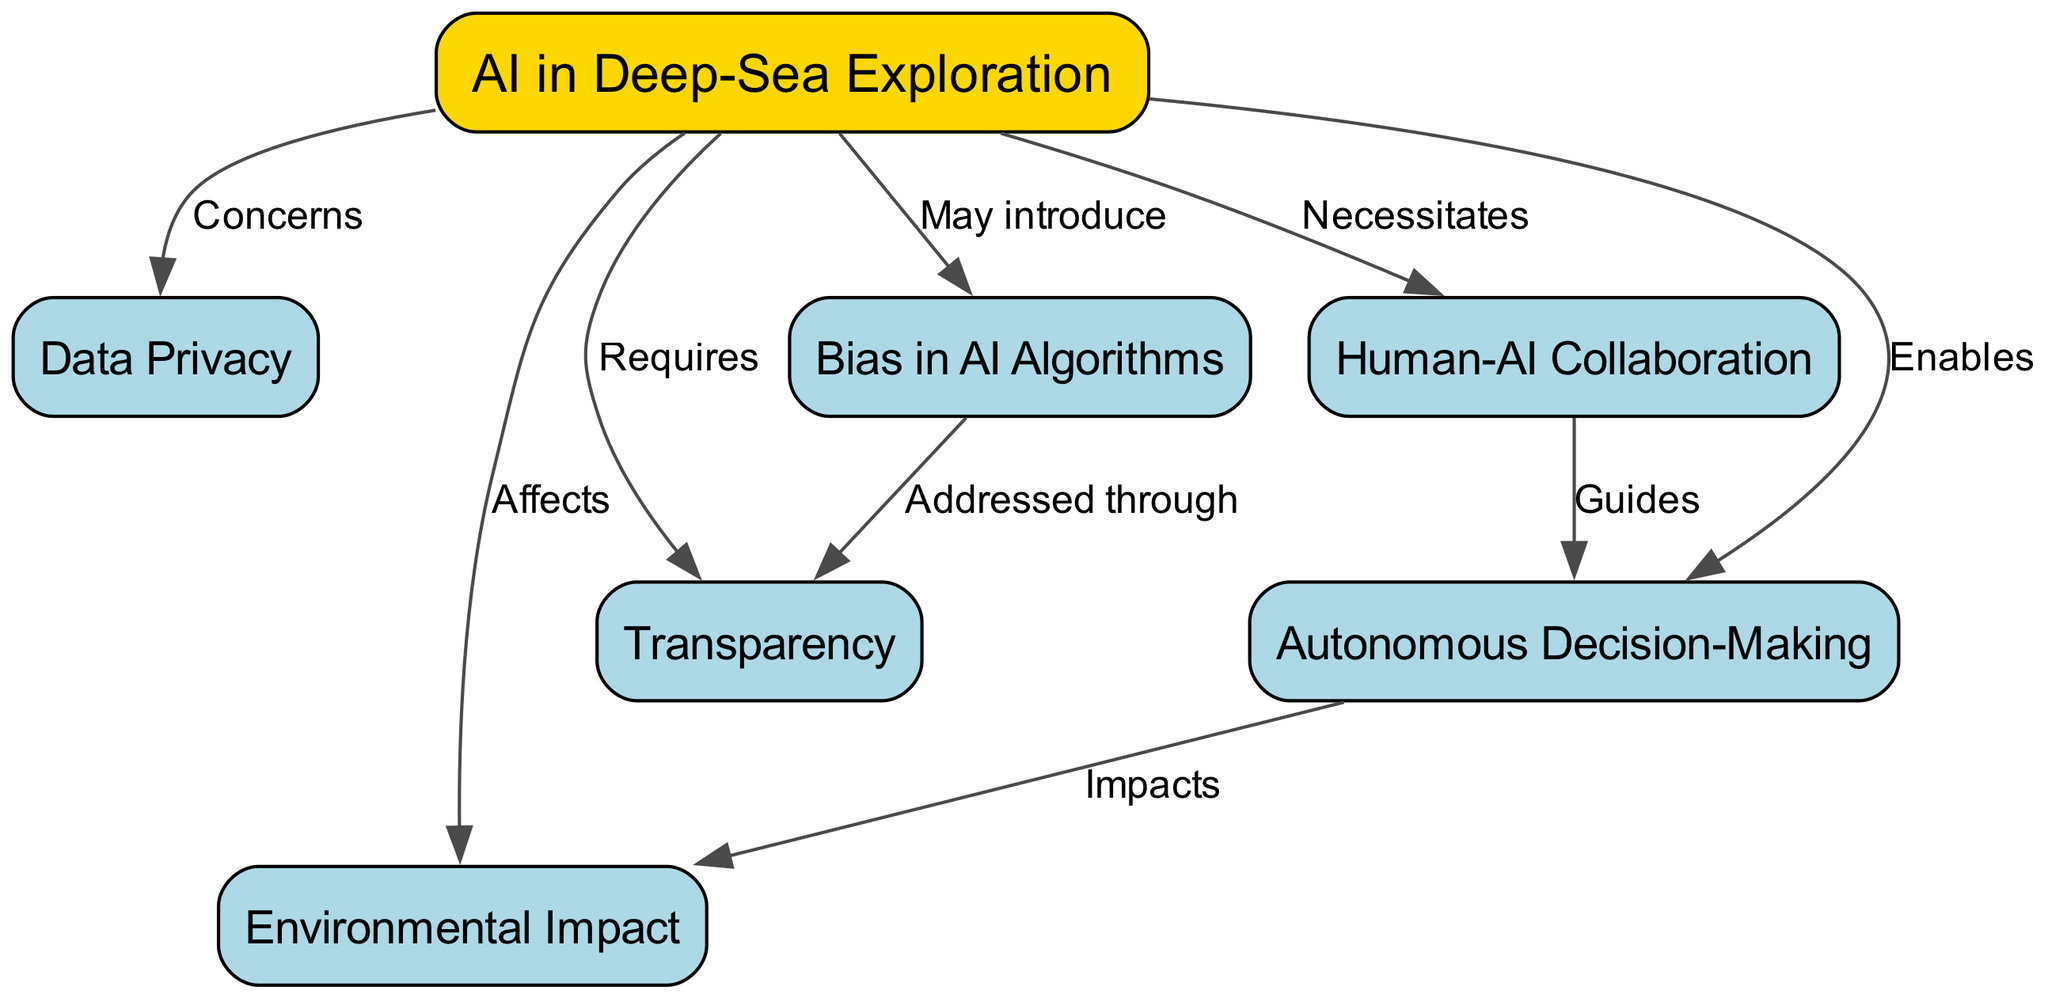What is the main topic of the concept map? The central node labeled "AI in Deep-Sea Exploration" represents the main topic around which the other nodes are connected. This node is emphasized by being the only one filled with gold.
Answer: AI in Deep-Sea Exploration How many total nodes are there in the diagram? Counting the nodes listed, there are seven distinct nodes: AI in Deep-Sea Exploration, Data Privacy, Environmental Impact, Autonomous Decision-Making, Transparency, Bias in AI Algorithms, and Human-AI Collaboration.
Answer: 7 What concern is related to Data Privacy? The diagram shows that Data Privacy is a concern stemming from "AI in Deep-Sea Exploration," as indicated by the edge labeled "Concerns."
Answer: Concerns What does Autonomous Decision-Making enable in the context of the diagram? The edge labeled "Enables" connects "AI in Deep-Sea Exploration" to "Autonomous Decision-Making," indicating that the application of AI facilitates the ability to make autonomous decisions in deep-sea exploration.
Answer: Enables How does Bias in AI Algorithms connect with Transparency? The diagram indicates that "Bias in AI Algorithms" can be addressed through "Transparency," establishing a connection where improving transparency may help mitigate bias issues in AI models.
Answer: Addressed through What impact does Autonomous Decision-Making have according to the diagram? There is a labeled edge "Impacts" connecting "Autonomous Decision-Making" to "Environmental Impact," implying that the use of autonomous systems may significantly affect the environment.
Answer: Impacts Which concept necessitates Human-AI Collaboration? The connection labeled "Necessitates" between "AI in Deep-Sea Exploration" and "Human-AI Collaboration" indicates that collaboration between human operators and AI systems is a crucial requirement in the implementation of AI for deep-sea research.
Answer: Necessitates How many relationships (edges) are shown in the diagram? By counting the edges provided in the data, there are a total of eight relationships connecting the seven nodes in various ways.
Answer: 8 What role does Transparency play in addressing AI biases according to the diagram? The diagram shows that Transparency is linked to Bias in AI Algorithms, stating that addressing bias in AI can be achieved by maintaining transparency in how AI algorithms operate and are developed.
Answer: Addressed through 